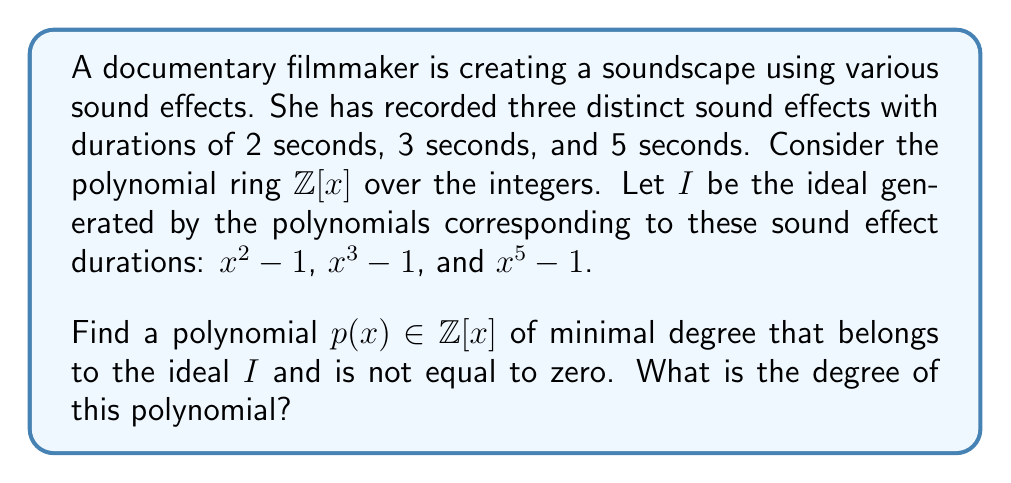Provide a solution to this math problem. Let's approach this step-by-step:

1) The ideal $I$ is generated by $\{x^2 - 1, x^3 - 1, x^5 - 1\}$.

2) Any polynomial in $I$ can be written as a linear combination of these generators:

   $p(x) = a(x)(x^2 - 1) + b(x)(x^3 - 1) + c(x)(x^5 - 1)$

   where $a(x)$, $b(x)$, and $c(x)$ are polynomials in $\mathbb{Z}[x]$.

3) We need to find the greatest common divisor (GCD) of these generators. Let's call it $g(x)$.

4) We can use the fact that $x^n - 1 = (x - 1)(x^{n-1} + x^{n-2} + ... + x + 1)$ for any positive integer $n$.

5) So, we have:
   $x^2 - 1 = (x - 1)(x + 1)$
   $x^3 - 1 = (x - 1)(x^2 + x + 1)$
   $x^5 - 1 = (x - 1)(x^4 + x^3 + x^2 + x + 1)$

6) We can see that $(x - 1)$ is a common factor of all these polynomials.

7) In fact, $(x - 1)$ is the GCD of these polynomials, as there are no other common factors.

8) Therefore, the polynomial of minimal degree in $I$ is $g(x) = x - 1$.

9) The degree of $g(x)$ is 1.
Answer: $x - 1$, degree 1 